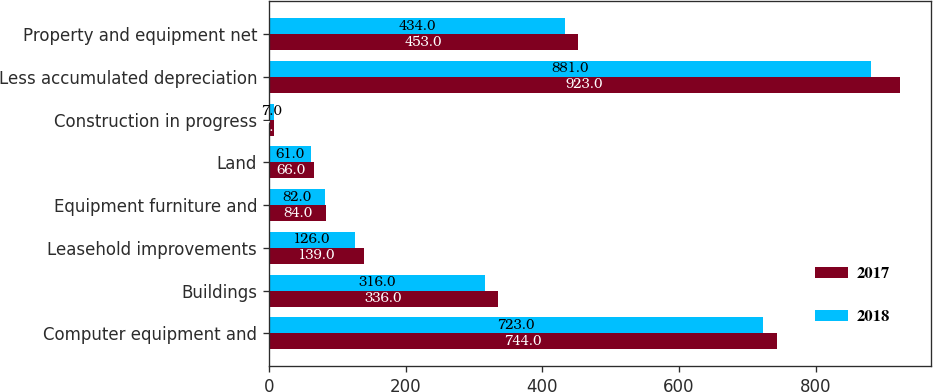Convert chart to OTSL. <chart><loc_0><loc_0><loc_500><loc_500><stacked_bar_chart><ecel><fcel>Computer equipment and<fcel>Buildings<fcel>Leasehold improvements<fcel>Equipment furniture and<fcel>Land<fcel>Construction in progress<fcel>Less accumulated depreciation<fcel>Property and equipment net<nl><fcel>2017<fcel>744<fcel>336<fcel>139<fcel>84<fcel>66<fcel>7<fcel>923<fcel>453<nl><fcel>2018<fcel>723<fcel>316<fcel>126<fcel>82<fcel>61<fcel>7<fcel>881<fcel>434<nl></chart> 